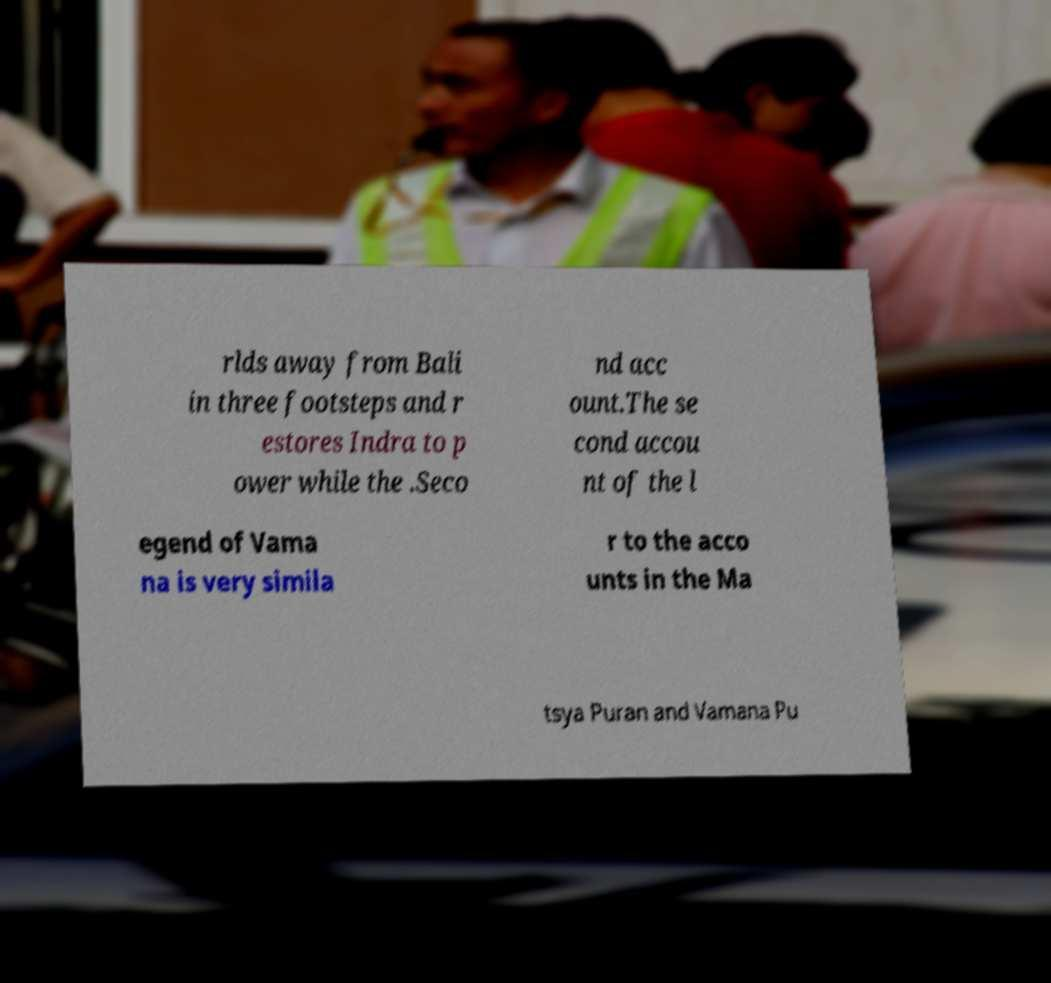Can you read and provide the text displayed in the image?This photo seems to have some interesting text. Can you extract and type it out for me? rlds away from Bali in three footsteps and r estores Indra to p ower while the .Seco nd acc ount.The se cond accou nt of the l egend of Vama na is very simila r to the acco unts in the Ma tsya Puran and Vamana Pu 